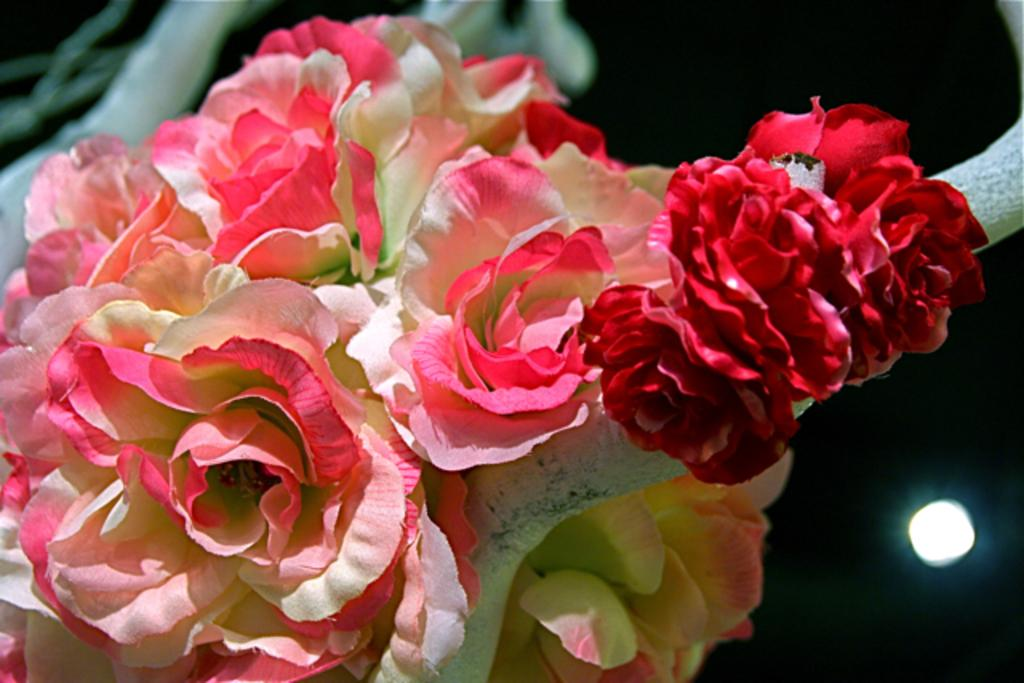What type of flowers are in the image? There are pink and red color roses in the image. How are the roses arranged? The roses are arranged in the image. What can be seen in the background of the image? There is a light in the background of the image. What is the color of the background in the image? The background is dark in color. What type of crack is visible in the image? There is no crack present in the image. How many cubes can be seen in the image? There are no cubes present in the image. 